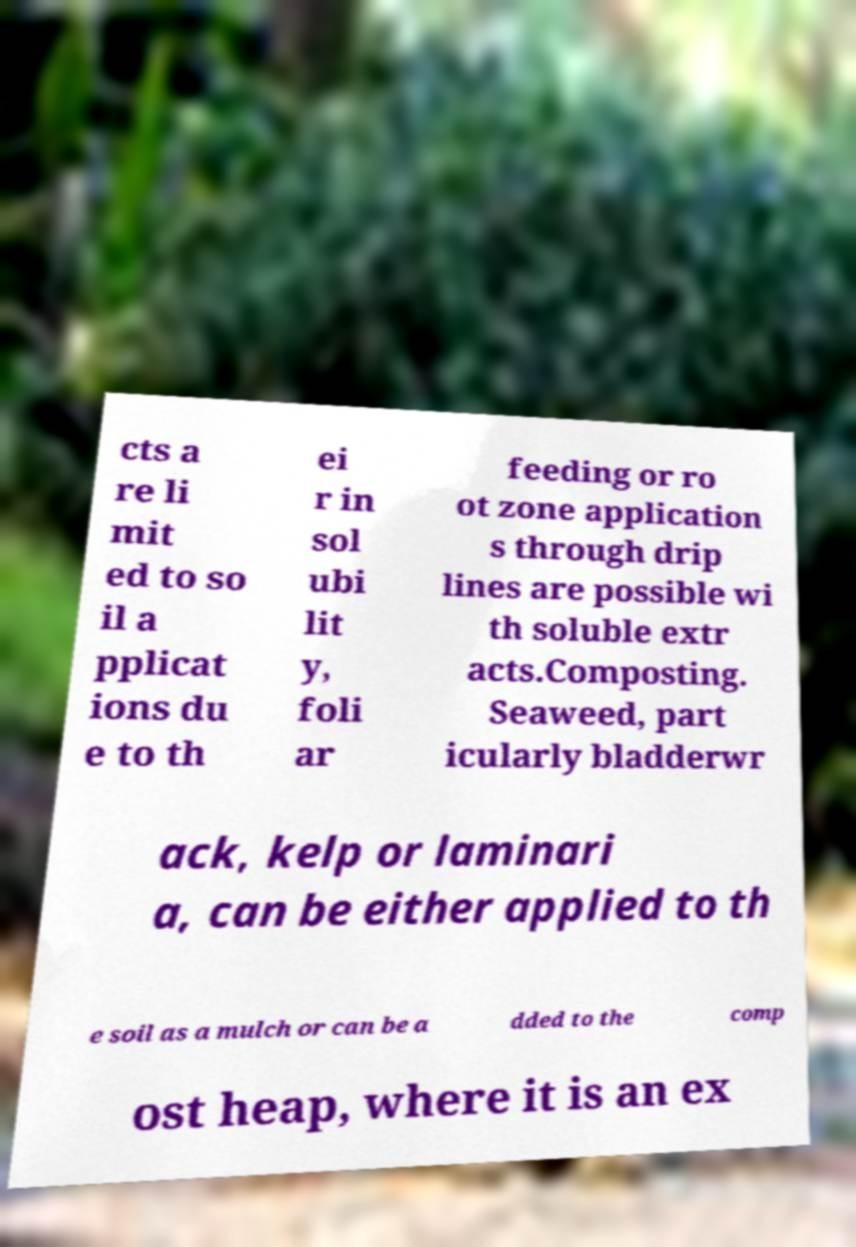What messages or text are displayed in this image? I need them in a readable, typed format. cts a re li mit ed to so il a pplicat ions du e to th ei r in sol ubi lit y, foli ar feeding or ro ot zone application s through drip lines are possible wi th soluble extr acts.Composting. Seaweed, part icularly bladderwr ack, kelp or laminari a, can be either applied to th e soil as a mulch or can be a dded to the comp ost heap, where it is an ex 